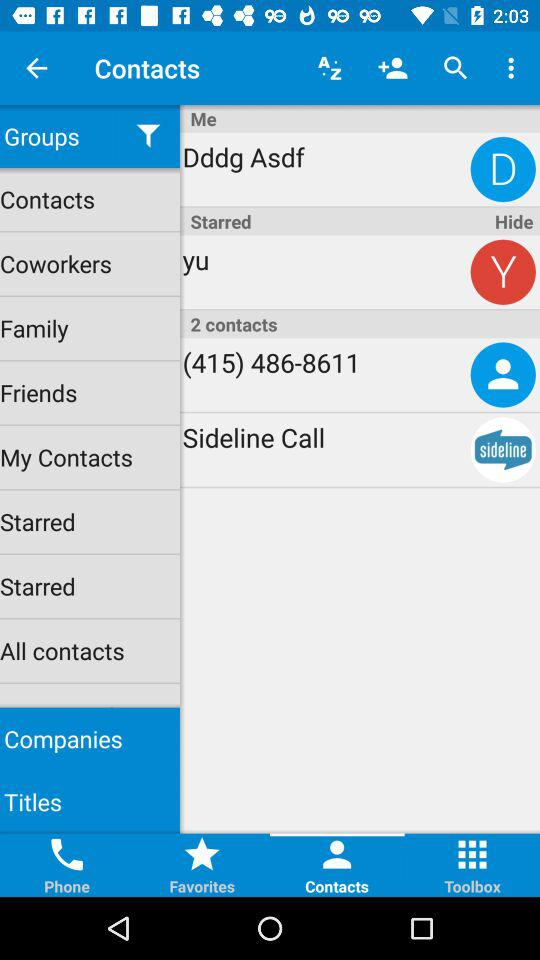Which tab is selected? The selected tab is "Contacts". 